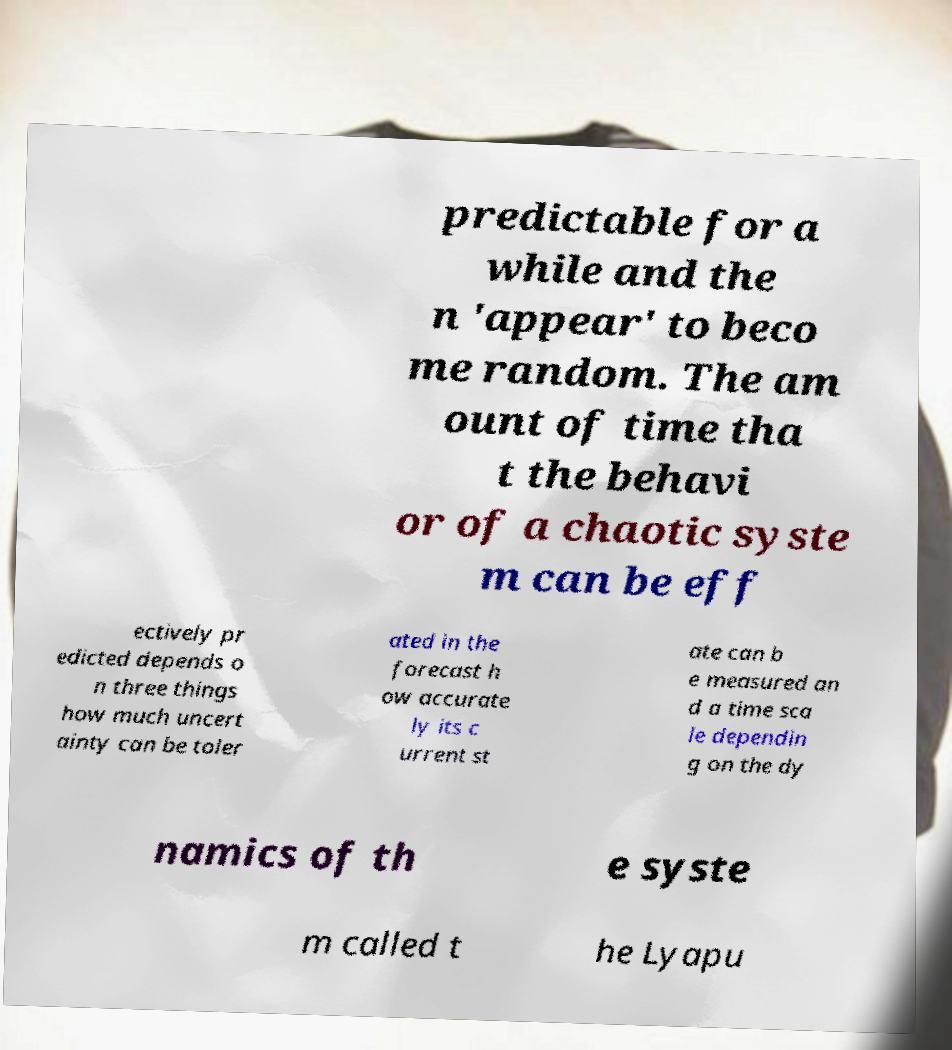What messages or text are displayed in this image? I need them in a readable, typed format. predictable for a while and the n 'appear' to beco me random. The am ount of time tha t the behavi or of a chaotic syste m can be eff ectively pr edicted depends o n three things how much uncert ainty can be toler ated in the forecast h ow accurate ly its c urrent st ate can b e measured an d a time sca le dependin g on the dy namics of th e syste m called t he Lyapu 